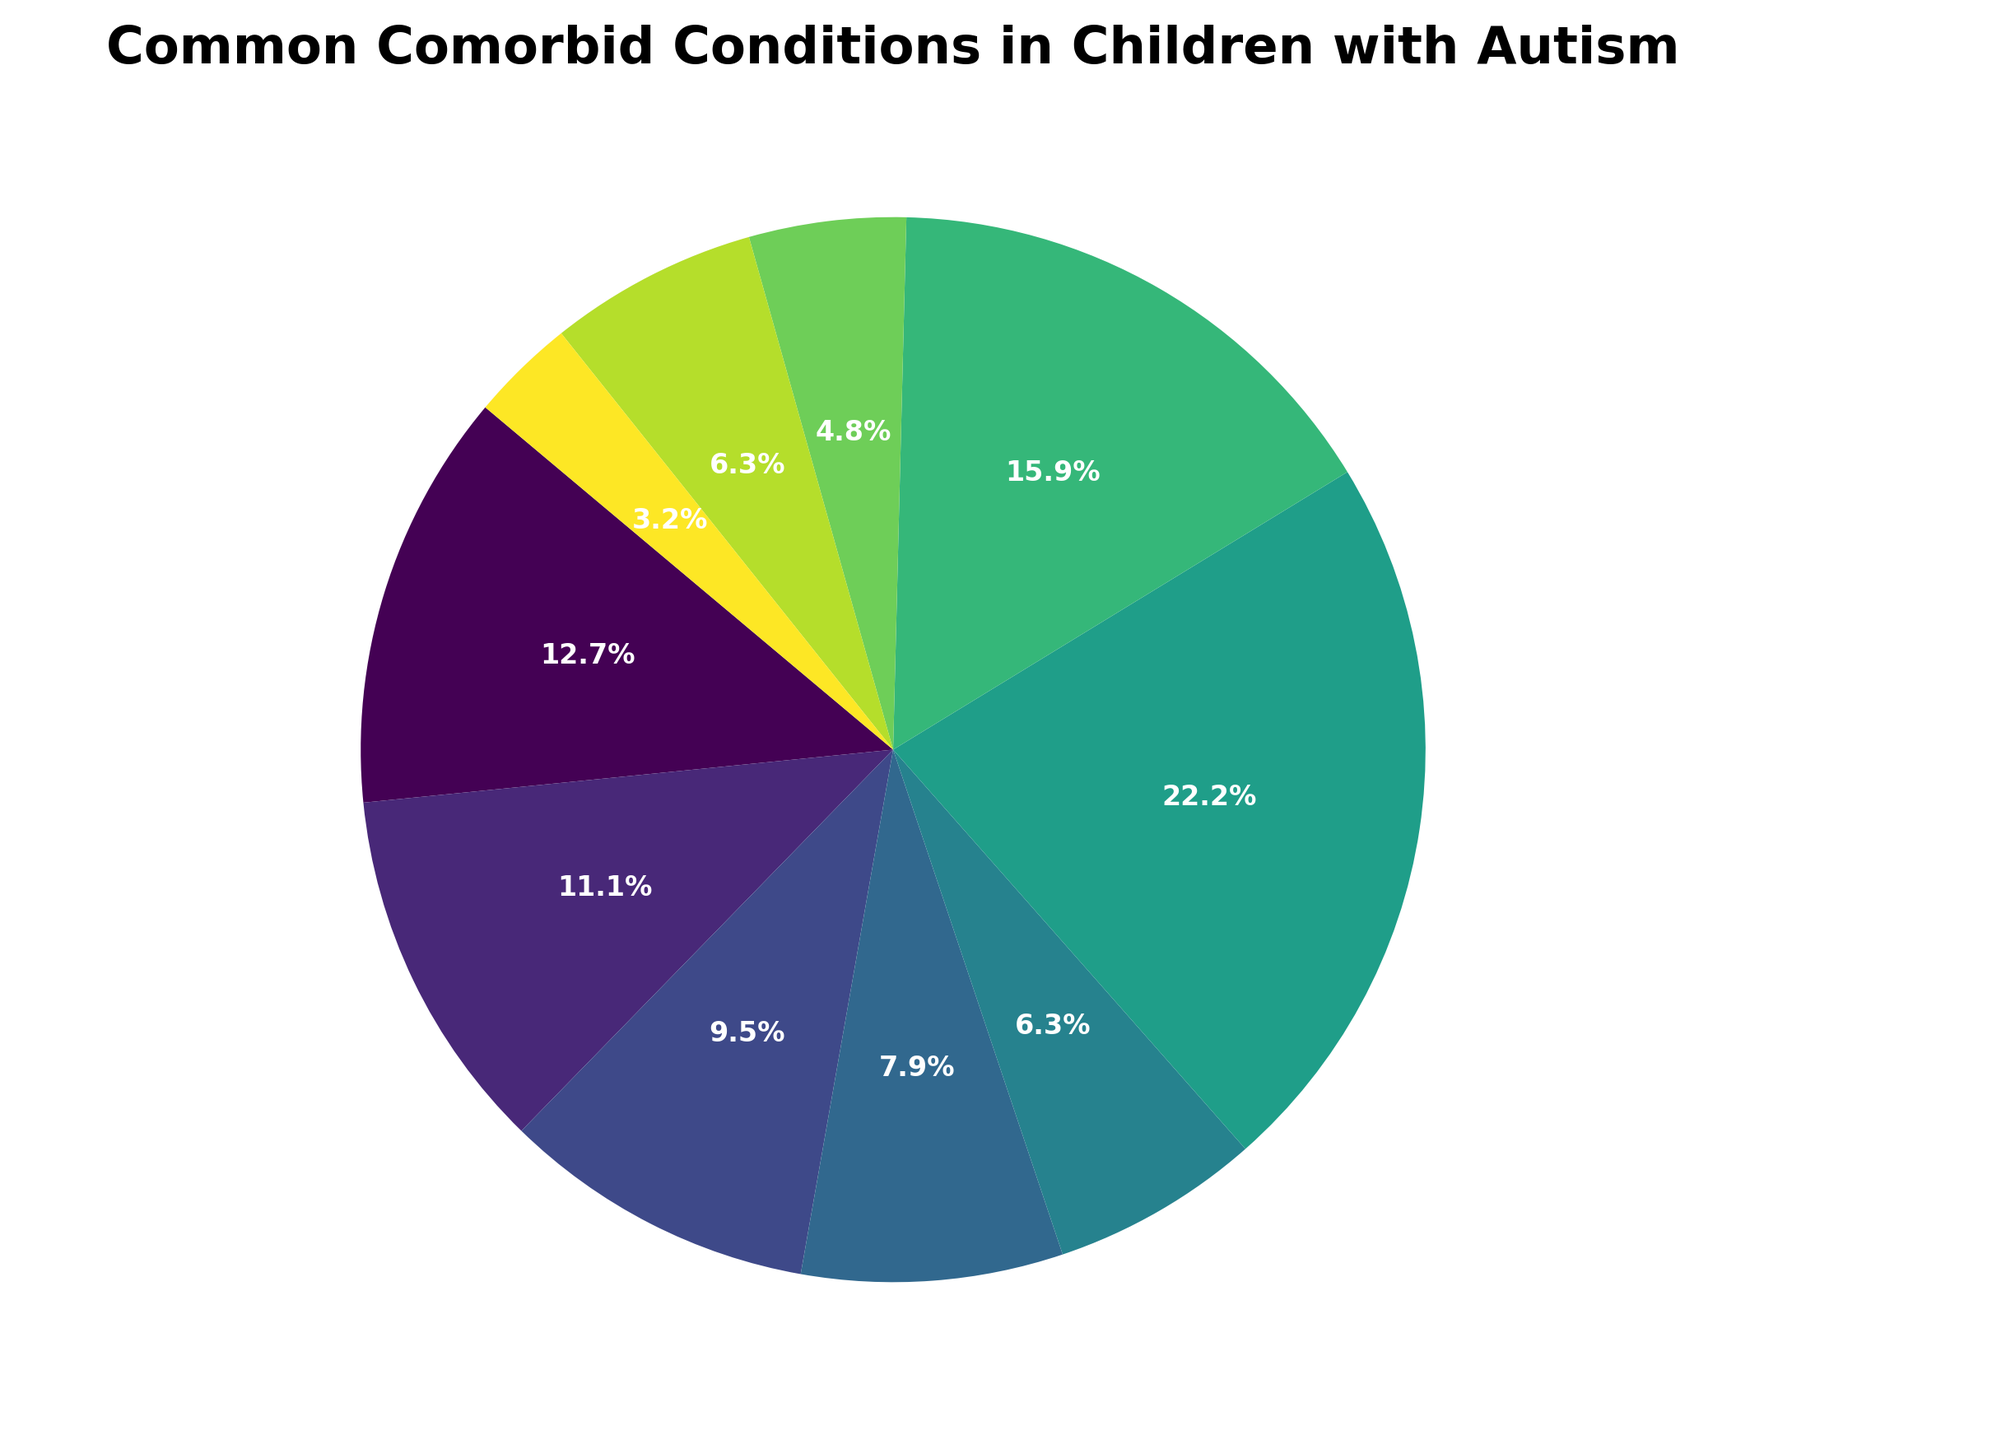Which condition has the highest percentage among children with autism? By looking at the pie chart, the condition with the largest slice is indicative of the highest percentage.
Answer: Sensory processing issues Which three conditions have the lowest percentages? Referring to the pie chart, identify the three smallest slices.
Answer: Tourette Syndrome, Obesity, Seizure disorders What is the combined percentage of children with autism who have ADHD and Anxiety disorders? Find the slices representing ADHD (40%) and Anxiety disorders (35%) and sum their percentages: 40% + 35% = 75%.
Answer: 75% Are Sleep disorders more common than Gastrointestinal issues in children with autism? Compare the size of the slices for Sleep disorders (25%) and Gastrointestinal issues (30%). Since 30% is greater than 25%, Gastrointestinal issues are more common.
Answer: No What is the percentage difference between children with autism who have Learning disabilities and those with Seizure disorders? Subtract the percentage of Seizure disorders (20%) from that of Learning disabilities (50%): 50% - 20% = 30%.
Answer: 30% Which condition constitutes exactly 10% of the children with autism? Identify the slice labeled with 10% in the pie chart.
Answer: Tourette Syndrome How many conditions occur in at least 25% of children with autism? Count the slices which are 25% or larger: Sensory processing issues (70%), ADHD (40%), Anxiety disorders (35%), Gastrointestinal issues (30%), and Sleep disorders (25%). There are 5 such conditions.
Answer: 5 What is the average percentage of children with autism who have Sleep disorders, Feeding disorders, and Obesity? Add the percentages of these three conditions and divide by 3: (25% + 20% + 15%) / 3 = 20%.
Answer: 20% What conditions are reported in 20% of children with autism? Identify the slices marked with 20% in the pie chart.
Answer: Seizure disorders, Feeding disorders Do Seizure disorders and Feeding disorders together affect more children than Learning disabilities? Sum the percentages for Seizure disorders (20%) and Feeding disorders (20%), then compare with Learning disabilities (50%): 20% + 20% = 40% which is less than 50%.
Answer: No 